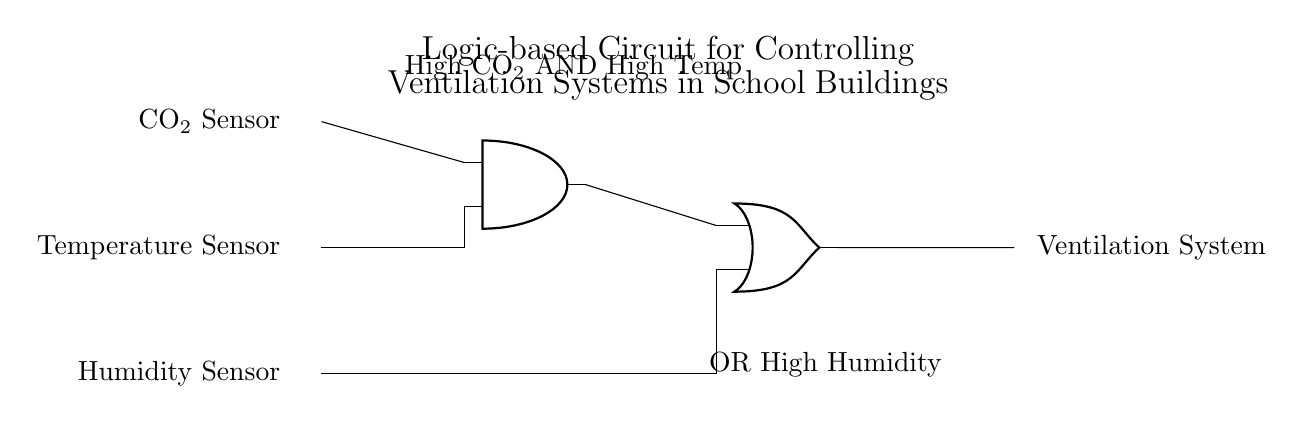What are the input sensors in the circuit? The circuit diagram shows three input sensors: a CO2 sensor, a temperature sensor, and a humidity sensor. These sensors are depicted at the left side of the circuit, indicating their role in monitoring the environmental conditions.
Answer: CO2 sensor, temperature sensor, humidity sensor What type of logic gate is used to combine CO2 and temperature signals? The circuit uses an AND gate to combine the outputs of the CO2 sensor and the temperature sensor. This is identified by the label of the gate in the diagram, indicating that both conditions must be met for the output to be active.
Answer: AND gate What is the purpose of the OR gate in this circuit? The OR gate combines the output from the AND gate and the humidity sensor. This functionality means that if either of the conditions from the AND gate or the humidity sensor is met, the output will activate the ventilation system.
Answer: To activate the ventilation system if either condition is met What must occur for the ventilation system to be activated? The ventilation system can be activated if there is high CO2 AND high temperature, or if there is high humidity. This is determined by the configuration of the AND and OR gates in the circuit, highlighting that any of these conditions can independently or jointly trigger the system.
Answer: High CO2 and high temperature, or high humidity How many inputs are there to the ventilation system? There are three inputs to the ventilation system, which are connected via the CO2 sensor, temperature sensor, and humidity sensor. These inputs are essential for measuring environmental conditions before control signals are sent to the system.
Answer: Three What does the AND gate output represent? The AND gate output represents the condition where both high CO2 levels and high temperature are detected simultaneously. This is a necessary signal for the ventilation system, as it indicates the need for air exchange in the building.
Answer: High CO2 and high temperature detected 